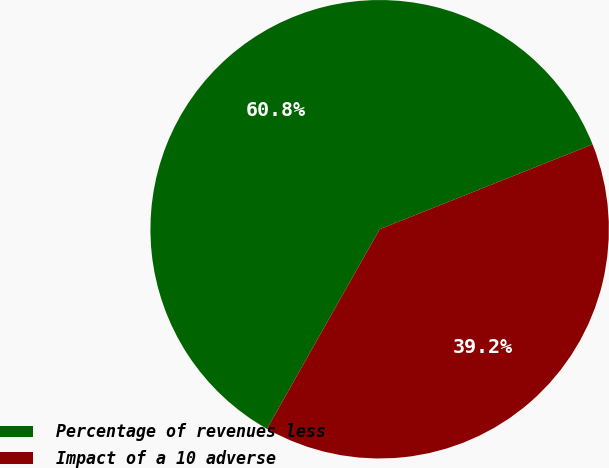Convert chart. <chart><loc_0><loc_0><loc_500><loc_500><pie_chart><fcel>Percentage of revenues less<fcel>Impact of a 10 adverse<nl><fcel>60.78%<fcel>39.22%<nl></chart> 